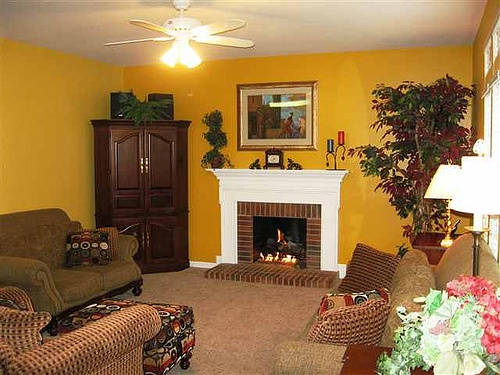Describe the objects in this image and their specific colors. I can see potted plant in gray, maroon, black, and olive tones, couch in gray, maroon, tan, and brown tones, couch in gray, maroon, and black tones, potted plant in gray, beige, lightpink, and lightgreen tones, and couch in gray, maroon, and brown tones in this image. 